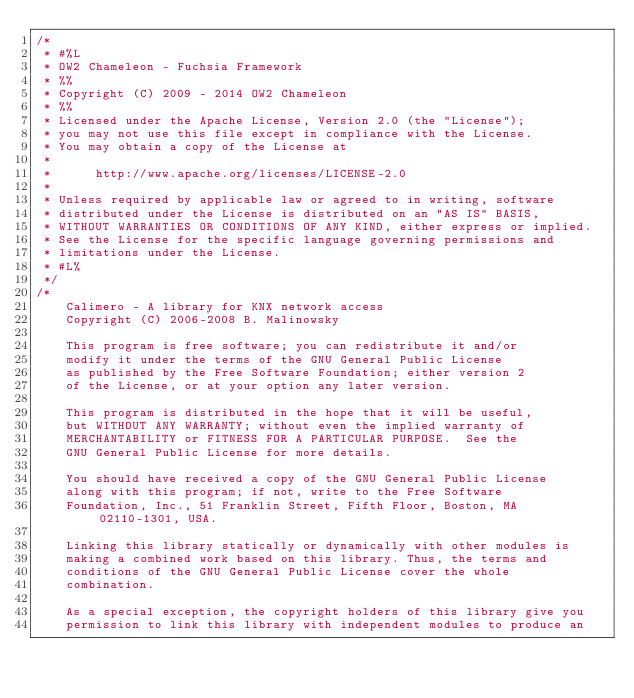<code> <loc_0><loc_0><loc_500><loc_500><_Java_>/*
 * #%L
 * OW2 Chameleon - Fuchsia Framework
 * %%
 * Copyright (C) 2009 - 2014 OW2 Chameleon
 * %%
 * Licensed under the Apache License, Version 2.0 (the "License");
 * you may not use this file except in compliance with the License.
 * You may obtain a copy of the License at
 * 
 *      http://www.apache.org/licenses/LICENSE-2.0
 * 
 * Unless required by applicable law or agreed to in writing, software
 * distributed under the License is distributed on an "AS IS" BASIS,
 * WITHOUT WARRANTIES OR CONDITIONS OF ANY KIND, either express or implied.
 * See the License for the specific language governing permissions and
 * limitations under the License.
 * #L%
 */
/*
    Calimero - A library for KNX network access
    Copyright (C) 2006-2008 B. Malinowsky

    This program is free software; you can redistribute it and/or 
    modify it under the terms of the GNU General Public License 
    as published by the Free Software Foundation; either version 2 
    of the License, or at your option any later version. 
 
    This program is distributed in the hope that it will be useful, 
    but WITHOUT ANY WARRANTY; without even the implied warranty of 
    MERCHANTABILITY or FITNESS FOR A PARTICULAR PURPOSE.  See the 
    GNU General Public License for more details. 
 
    You should have received a copy of the GNU General Public License 
    along with this program; if not, write to the Free Software 
    Foundation, Inc., 51 Franklin Street, Fifth Floor, Boston, MA  02110-1301, USA. 
 
    Linking this library statically or dynamically with other modules is 
    making a combined work based on this library. Thus, the terms and 
    conditions of the GNU General Public License cover the whole 
    combination. 
 
    As a special exception, the copyright holders of this library give you 
    permission to link this library with independent modules to produce an </code> 